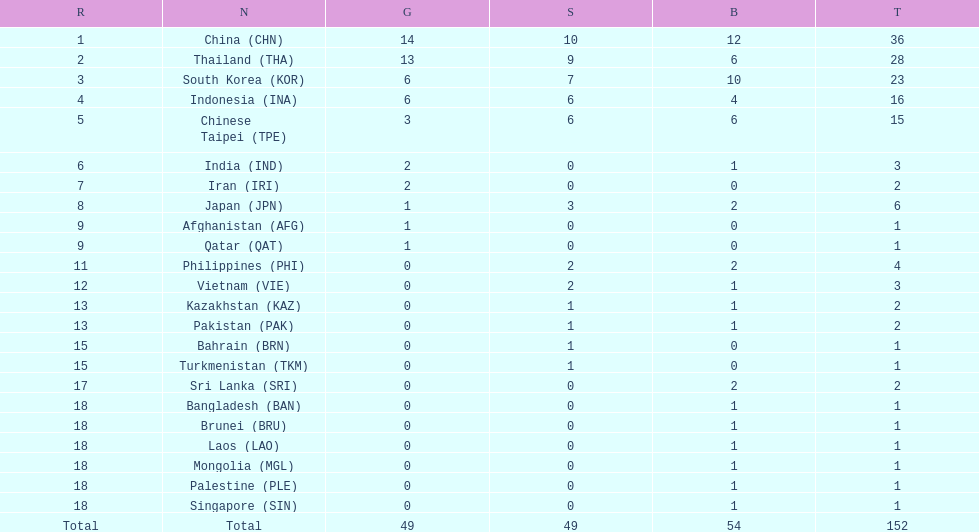How many nations received a medal in each gold, silver, and bronze? 6. 